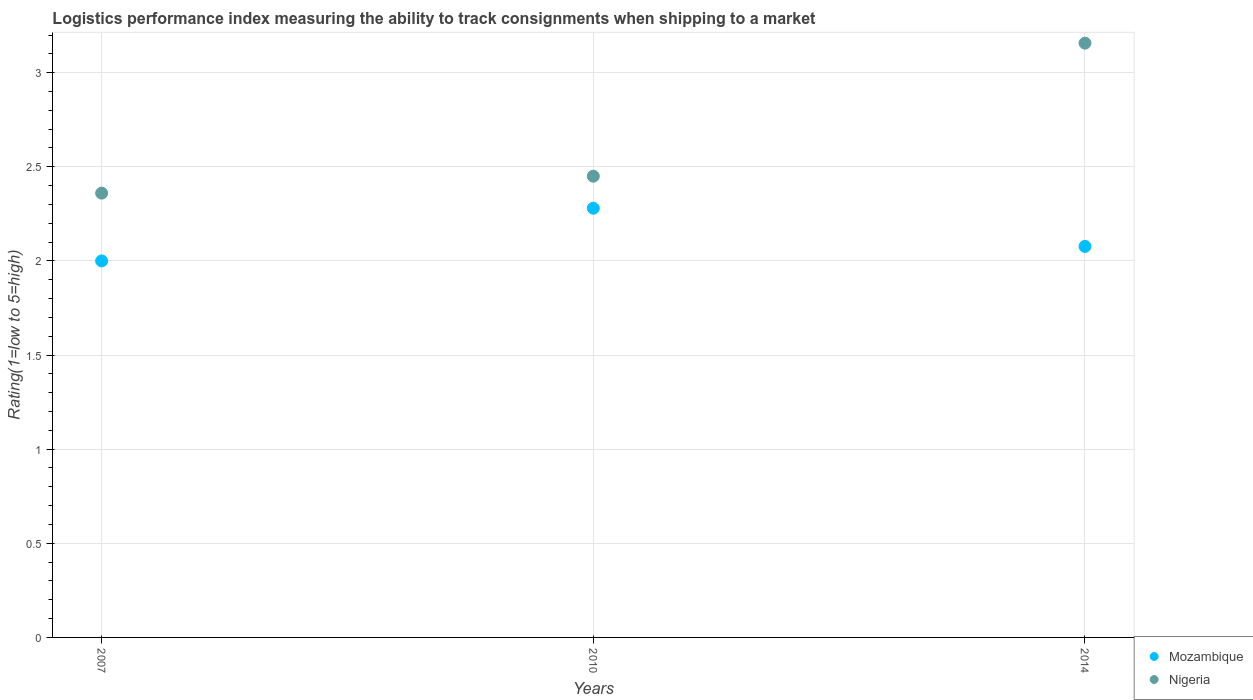Is the number of dotlines equal to the number of legend labels?
Make the answer very short. Yes. What is the Logistic performance index in Mozambique in 2014?
Your response must be concise. 2.08. Across all years, what is the maximum Logistic performance index in Mozambique?
Give a very brief answer. 2.28. In which year was the Logistic performance index in Nigeria maximum?
Provide a succinct answer. 2014. What is the total Logistic performance index in Mozambique in the graph?
Your response must be concise. 6.36. What is the difference between the Logistic performance index in Mozambique in 2007 and that in 2010?
Provide a short and direct response. -0.28. What is the difference between the Logistic performance index in Mozambique in 2014 and the Logistic performance index in Nigeria in 2010?
Provide a succinct answer. -0.37. What is the average Logistic performance index in Nigeria per year?
Give a very brief answer. 2.66. In the year 2010, what is the difference between the Logistic performance index in Mozambique and Logistic performance index in Nigeria?
Your answer should be very brief. -0.17. In how many years, is the Logistic performance index in Mozambique greater than 0.30000000000000004?
Ensure brevity in your answer.  3. What is the ratio of the Logistic performance index in Nigeria in 2007 to that in 2014?
Ensure brevity in your answer.  0.75. Is the Logistic performance index in Nigeria in 2007 less than that in 2010?
Offer a very short reply. Yes. Is the difference between the Logistic performance index in Mozambique in 2010 and 2014 greater than the difference between the Logistic performance index in Nigeria in 2010 and 2014?
Provide a succinct answer. Yes. What is the difference between the highest and the second highest Logistic performance index in Mozambique?
Give a very brief answer. 0.2. What is the difference between the highest and the lowest Logistic performance index in Mozambique?
Offer a terse response. 0.28. In how many years, is the Logistic performance index in Mozambique greater than the average Logistic performance index in Mozambique taken over all years?
Your answer should be very brief. 1. Is the sum of the Logistic performance index in Nigeria in 2010 and 2014 greater than the maximum Logistic performance index in Mozambique across all years?
Your answer should be compact. Yes. Is the Logistic performance index in Mozambique strictly less than the Logistic performance index in Nigeria over the years?
Give a very brief answer. Yes. How many years are there in the graph?
Provide a short and direct response. 3. What is the difference between two consecutive major ticks on the Y-axis?
Give a very brief answer. 0.5. Where does the legend appear in the graph?
Your answer should be very brief. Bottom right. How many legend labels are there?
Offer a terse response. 2. What is the title of the graph?
Offer a terse response. Logistics performance index measuring the ability to track consignments when shipping to a market. Does "Other small states" appear as one of the legend labels in the graph?
Give a very brief answer. No. What is the label or title of the Y-axis?
Ensure brevity in your answer.  Rating(1=low to 5=high). What is the Rating(1=low to 5=high) in Mozambique in 2007?
Provide a succinct answer. 2. What is the Rating(1=low to 5=high) of Nigeria in 2007?
Make the answer very short. 2.36. What is the Rating(1=low to 5=high) of Mozambique in 2010?
Keep it short and to the point. 2.28. What is the Rating(1=low to 5=high) in Nigeria in 2010?
Offer a very short reply. 2.45. What is the Rating(1=low to 5=high) of Mozambique in 2014?
Provide a succinct answer. 2.08. What is the Rating(1=low to 5=high) of Nigeria in 2014?
Ensure brevity in your answer.  3.16. Across all years, what is the maximum Rating(1=low to 5=high) of Mozambique?
Give a very brief answer. 2.28. Across all years, what is the maximum Rating(1=low to 5=high) in Nigeria?
Give a very brief answer. 3.16. Across all years, what is the minimum Rating(1=low to 5=high) in Nigeria?
Offer a terse response. 2.36. What is the total Rating(1=low to 5=high) in Mozambique in the graph?
Give a very brief answer. 6.36. What is the total Rating(1=low to 5=high) of Nigeria in the graph?
Your answer should be very brief. 7.97. What is the difference between the Rating(1=low to 5=high) of Mozambique in 2007 and that in 2010?
Provide a succinct answer. -0.28. What is the difference between the Rating(1=low to 5=high) of Nigeria in 2007 and that in 2010?
Your answer should be very brief. -0.09. What is the difference between the Rating(1=low to 5=high) of Mozambique in 2007 and that in 2014?
Offer a terse response. -0.08. What is the difference between the Rating(1=low to 5=high) of Nigeria in 2007 and that in 2014?
Your answer should be very brief. -0.8. What is the difference between the Rating(1=low to 5=high) in Mozambique in 2010 and that in 2014?
Provide a short and direct response. 0.2. What is the difference between the Rating(1=low to 5=high) in Nigeria in 2010 and that in 2014?
Keep it short and to the point. -0.71. What is the difference between the Rating(1=low to 5=high) in Mozambique in 2007 and the Rating(1=low to 5=high) in Nigeria in 2010?
Your answer should be compact. -0.45. What is the difference between the Rating(1=low to 5=high) in Mozambique in 2007 and the Rating(1=low to 5=high) in Nigeria in 2014?
Give a very brief answer. -1.16. What is the difference between the Rating(1=low to 5=high) in Mozambique in 2010 and the Rating(1=low to 5=high) in Nigeria in 2014?
Your response must be concise. -0.88. What is the average Rating(1=low to 5=high) of Mozambique per year?
Ensure brevity in your answer.  2.12. What is the average Rating(1=low to 5=high) in Nigeria per year?
Ensure brevity in your answer.  2.66. In the year 2007, what is the difference between the Rating(1=low to 5=high) of Mozambique and Rating(1=low to 5=high) of Nigeria?
Your answer should be compact. -0.36. In the year 2010, what is the difference between the Rating(1=low to 5=high) of Mozambique and Rating(1=low to 5=high) of Nigeria?
Your answer should be very brief. -0.17. In the year 2014, what is the difference between the Rating(1=low to 5=high) of Mozambique and Rating(1=low to 5=high) of Nigeria?
Your answer should be compact. -1.08. What is the ratio of the Rating(1=low to 5=high) of Mozambique in 2007 to that in 2010?
Keep it short and to the point. 0.88. What is the ratio of the Rating(1=low to 5=high) in Nigeria in 2007 to that in 2010?
Your answer should be compact. 0.96. What is the ratio of the Rating(1=low to 5=high) of Mozambique in 2007 to that in 2014?
Your answer should be compact. 0.96. What is the ratio of the Rating(1=low to 5=high) in Nigeria in 2007 to that in 2014?
Offer a very short reply. 0.75. What is the ratio of the Rating(1=low to 5=high) in Mozambique in 2010 to that in 2014?
Offer a very short reply. 1.1. What is the ratio of the Rating(1=low to 5=high) of Nigeria in 2010 to that in 2014?
Your response must be concise. 0.78. What is the difference between the highest and the second highest Rating(1=low to 5=high) in Mozambique?
Make the answer very short. 0.2. What is the difference between the highest and the second highest Rating(1=low to 5=high) of Nigeria?
Offer a terse response. 0.71. What is the difference between the highest and the lowest Rating(1=low to 5=high) in Mozambique?
Keep it short and to the point. 0.28. What is the difference between the highest and the lowest Rating(1=low to 5=high) in Nigeria?
Keep it short and to the point. 0.8. 